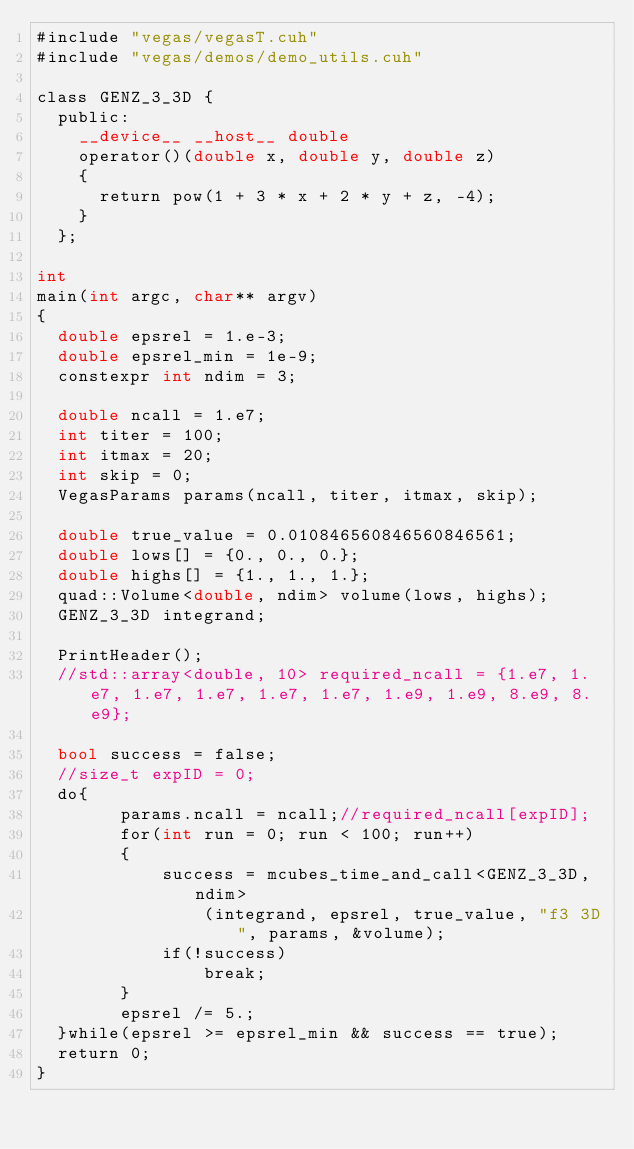<code> <loc_0><loc_0><loc_500><loc_500><_Cuda_>#include "vegas/vegasT.cuh"
#include "vegas/demos/demo_utils.cuh"

class GENZ_3_3D {
  public:
    __device__ __host__ double
    operator()(double x, double y, double z)
    {
      return pow(1 + 3 * x + 2 * y + z, -4);
    }
  };
  
int
main(int argc, char** argv)
{
  double epsrel = 1.e-3;
  double epsrel_min = 1e-9;
  constexpr int ndim = 3;
  
  double ncall = 1.e7;
  int titer = 100;
  int itmax = 20;
  int skip = 0;
  VegasParams params(ncall, titer, itmax, skip);
  
  double true_value = 0.010846560846560846561;
  double lows[] = {0., 0., 0.};
  double highs[] = {1., 1., 1.};
  quad::Volume<double, ndim> volume(lows, highs);
  GENZ_3_3D integrand;
  
  PrintHeader();
  //std::array<double, 10> required_ncall = {1.e7, 1.e7, 1.e7, 1.e7, 1.e7, 1.e7, 1.e9, 1.e9, 8.e9, 8.e9};

  bool success = false;
  //size_t expID = 0;
  do{
        params.ncall = ncall;//required_ncall[expID];
        for(int run = 0; run < 100; run++)
        {
            success = mcubes_time_and_call<GENZ_3_3D, ndim>
                (integrand, epsrel, true_value, "f3 3D", params, &volume);
            if(!success)
                break;
        }
        epsrel /= 5.;
  }while(epsrel >= epsrel_min && success == true); 
  return 0;
}</code> 